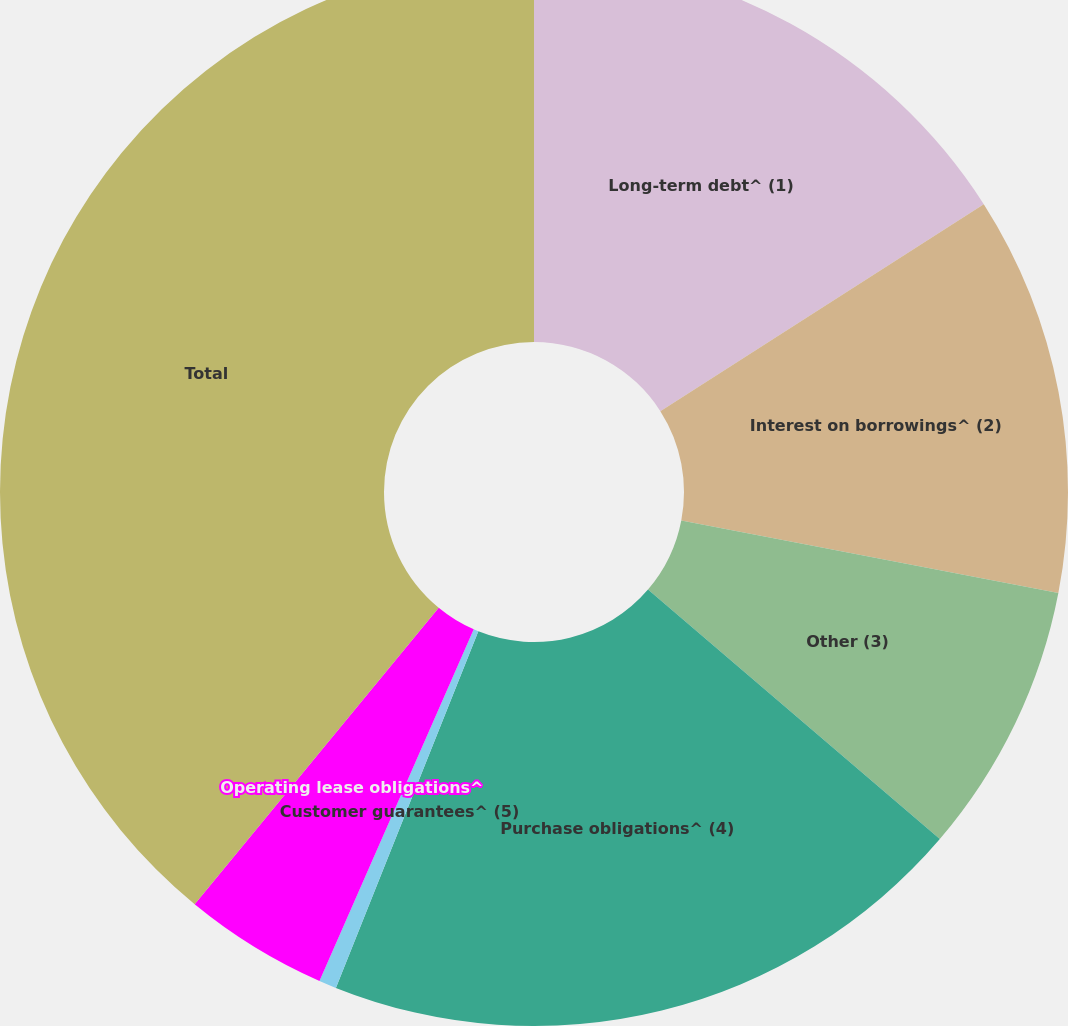<chart> <loc_0><loc_0><loc_500><loc_500><pie_chart><fcel>Long-term debt^ (1)<fcel>Interest on borrowings^ (2)<fcel>Other (3)<fcel>Purchase obligations^ (4)<fcel>Customer guarantees^ (5)<fcel>Operating lease obligations^<fcel>Total<nl><fcel>15.94%<fcel>12.09%<fcel>8.23%<fcel>19.79%<fcel>0.53%<fcel>4.38%<fcel>39.04%<nl></chart> 